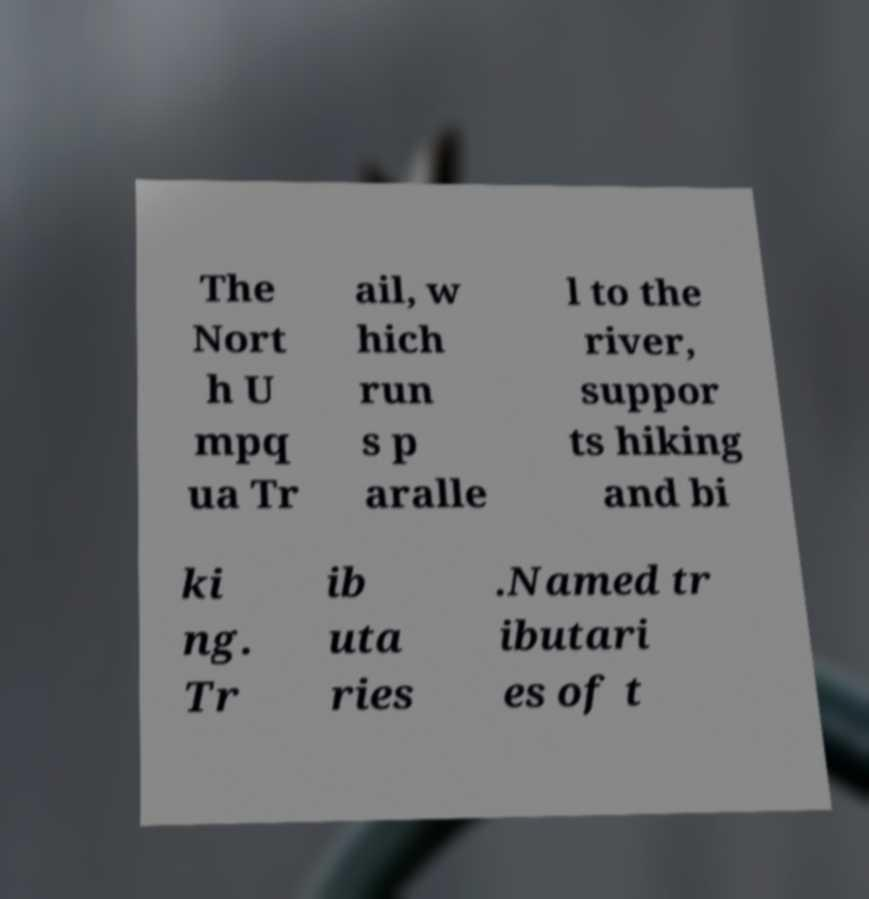Can you read and provide the text displayed in the image?This photo seems to have some interesting text. Can you extract and type it out for me? The Nort h U mpq ua Tr ail, w hich run s p aralle l to the river, suppor ts hiking and bi ki ng. Tr ib uta ries .Named tr ibutari es of t 